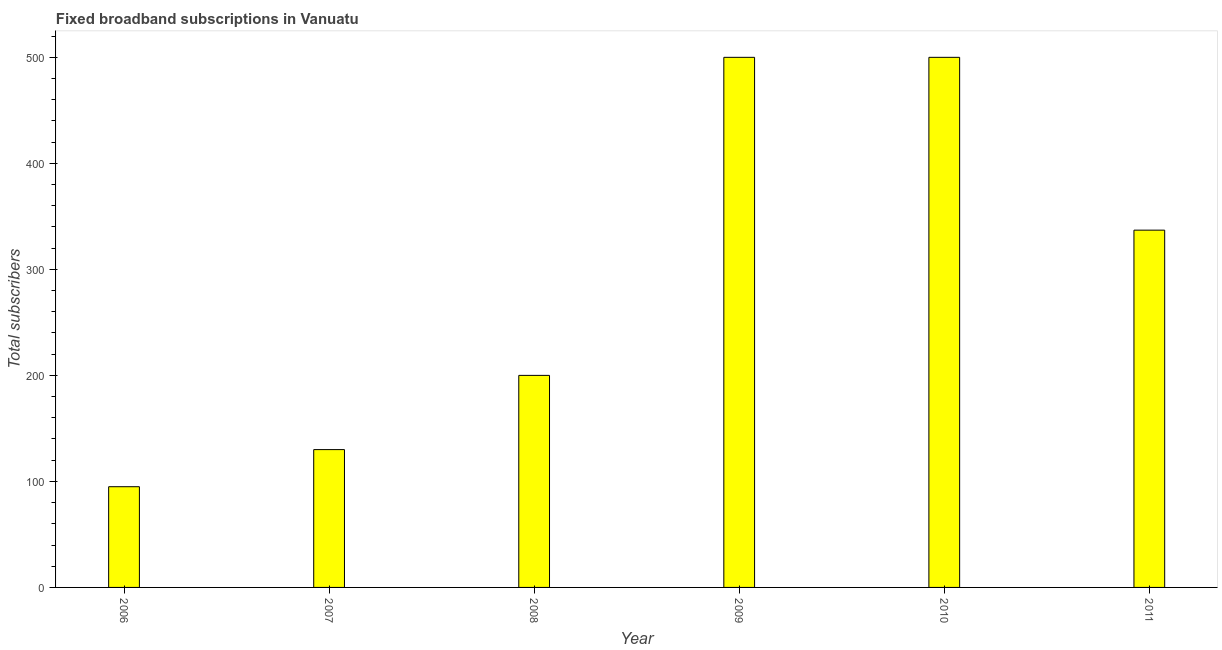Does the graph contain grids?
Offer a very short reply. No. What is the title of the graph?
Your response must be concise. Fixed broadband subscriptions in Vanuatu. What is the label or title of the Y-axis?
Offer a very short reply. Total subscribers. What is the total number of fixed broadband subscriptions in 2009?
Your response must be concise. 500. Across all years, what is the minimum total number of fixed broadband subscriptions?
Offer a terse response. 95. In which year was the total number of fixed broadband subscriptions maximum?
Your response must be concise. 2009. In which year was the total number of fixed broadband subscriptions minimum?
Give a very brief answer. 2006. What is the sum of the total number of fixed broadband subscriptions?
Give a very brief answer. 1762. What is the difference between the total number of fixed broadband subscriptions in 2009 and 2011?
Make the answer very short. 163. What is the average total number of fixed broadband subscriptions per year?
Offer a very short reply. 293. What is the median total number of fixed broadband subscriptions?
Provide a succinct answer. 268.5. Do a majority of the years between 2008 and 2009 (inclusive) have total number of fixed broadband subscriptions greater than 400 ?
Make the answer very short. No. What is the ratio of the total number of fixed broadband subscriptions in 2007 to that in 2011?
Offer a terse response. 0.39. Is the difference between the total number of fixed broadband subscriptions in 2009 and 2010 greater than the difference between any two years?
Your answer should be very brief. No. What is the difference between the highest and the lowest total number of fixed broadband subscriptions?
Offer a terse response. 405. How many bars are there?
Your response must be concise. 6. Are all the bars in the graph horizontal?
Keep it short and to the point. No. What is the Total subscribers of 2007?
Give a very brief answer. 130. What is the Total subscribers of 2008?
Provide a short and direct response. 200. What is the Total subscribers of 2010?
Your answer should be compact. 500. What is the Total subscribers of 2011?
Your answer should be compact. 337. What is the difference between the Total subscribers in 2006 and 2007?
Make the answer very short. -35. What is the difference between the Total subscribers in 2006 and 2008?
Offer a very short reply. -105. What is the difference between the Total subscribers in 2006 and 2009?
Provide a succinct answer. -405. What is the difference between the Total subscribers in 2006 and 2010?
Provide a short and direct response. -405. What is the difference between the Total subscribers in 2006 and 2011?
Your response must be concise. -242. What is the difference between the Total subscribers in 2007 and 2008?
Ensure brevity in your answer.  -70. What is the difference between the Total subscribers in 2007 and 2009?
Provide a short and direct response. -370. What is the difference between the Total subscribers in 2007 and 2010?
Make the answer very short. -370. What is the difference between the Total subscribers in 2007 and 2011?
Your answer should be very brief. -207. What is the difference between the Total subscribers in 2008 and 2009?
Offer a very short reply. -300. What is the difference between the Total subscribers in 2008 and 2010?
Your answer should be compact. -300. What is the difference between the Total subscribers in 2008 and 2011?
Provide a short and direct response. -137. What is the difference between the Total subscribers in 2009 and 2010?
Provide a succinct answer. 0. What is the difference between the Total subscribers in 2009 and 2011?
Provide a short and direct response. 163. What is the difference between the Total subscribers in 2010 and 2011?
Give a very brief answer. 163. What is the ratio of the Total subscribers in 2006 to that in 2007?
Your answer should be compact. 0.73. What is the ratio of the Total subscribers in 2006 to that in 2008?
Offer a terse response. 0.47. What is the ratio of the Total subscribers in 2006 to that in 2009?
Give a very brief answer. 0.19. What is the ratio of the Total subscribers in 2006 to that in 2010?
Your response must be concise. 0.19. What is the ratio of the Total subscribers in 2006 to that in 2011?
Give a very brief answer. 0.28. What is the ratio of the Total subscribers in 2007 to that in 2008?
Give a very brief answer. 0.65. What is the ratio of the Total subscribers in 2007 to that in 2009?
Your response must be concise. 0.26. What is the ratio of the Total subscribers in 2007 to that in 2010?
Give a very brief answer. 0.26. What is the ratio of the Total subscribers in 2007 to that in 2011?
Give a very brief answer. 0.39. What is the ratio of the Total subscribers in 2008 to that in 2011?
Give a very brief answer. 0.59. What is the ratio of the Total subscribers in 2009 to that in 2010?
Your answer should be very brief. 1. What is the ratio of the Total subscribers in 2009 to that in 2011?
Your response must be concise. 1.48. What is the ratio of the Total subscribers in 2010 to that in 2011?
Offer a terse response. 1.48. 